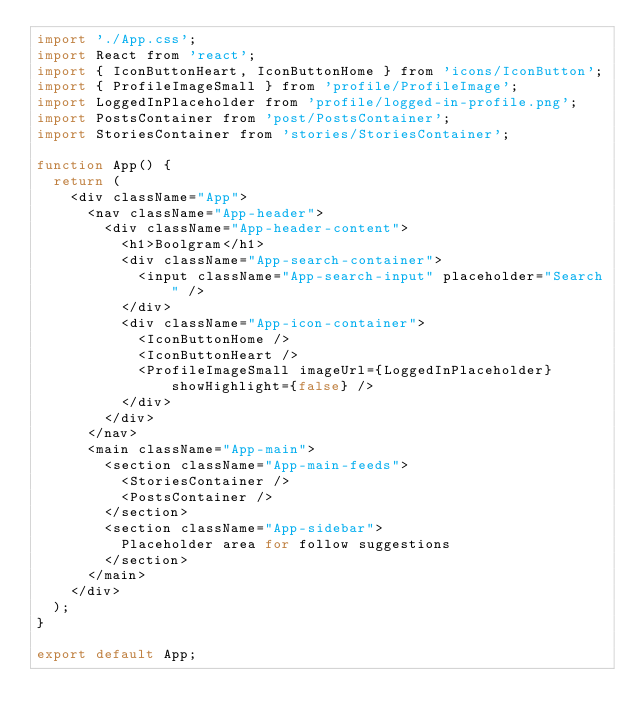Convert code to text. <code><loc_0><loc_0><loc_500><loc_500><_JavaScript_>import './App.css';
import React from 'react';
import { IconButtonHeart, IconButtonHome } from 'icons/IconButton';
import { ProfileImageSmall } from 'profile/ProfileImage';
import LoggedInPlaceholder from 'profile/logged-in-profile.png';
import PostsContainer from 'post/PostsContainer';
import StoriesContainer from 'stories/StoriesContainer';

function App() {
  return (
    <div className="App">
      <nav className="App-header">
        <div className="App-header-content">
          <h1>Boolgram</h1>
          <div className="App-search-container">
            <input className="App-search-input" placeholder="Search" />
          </div>
          <div className="App-icon-container">
            <IconButtonHome />
            <IconButtonHeart />
            <ProfileImageSmall imageUrl={LoggedInPlaceholder} showHighlight={false} />
          </div>
        </div>
      </nav>
      <main className="App-main">
        <section className="App-main-feeds">
          <StoriesContainer />
          <PostsContainer />
        </section>
        <section className="App-sidebar">
          Placeholder area for follow suggestions
        </section>
      </main>
    </div>
  );
}

export default App;
</code> 